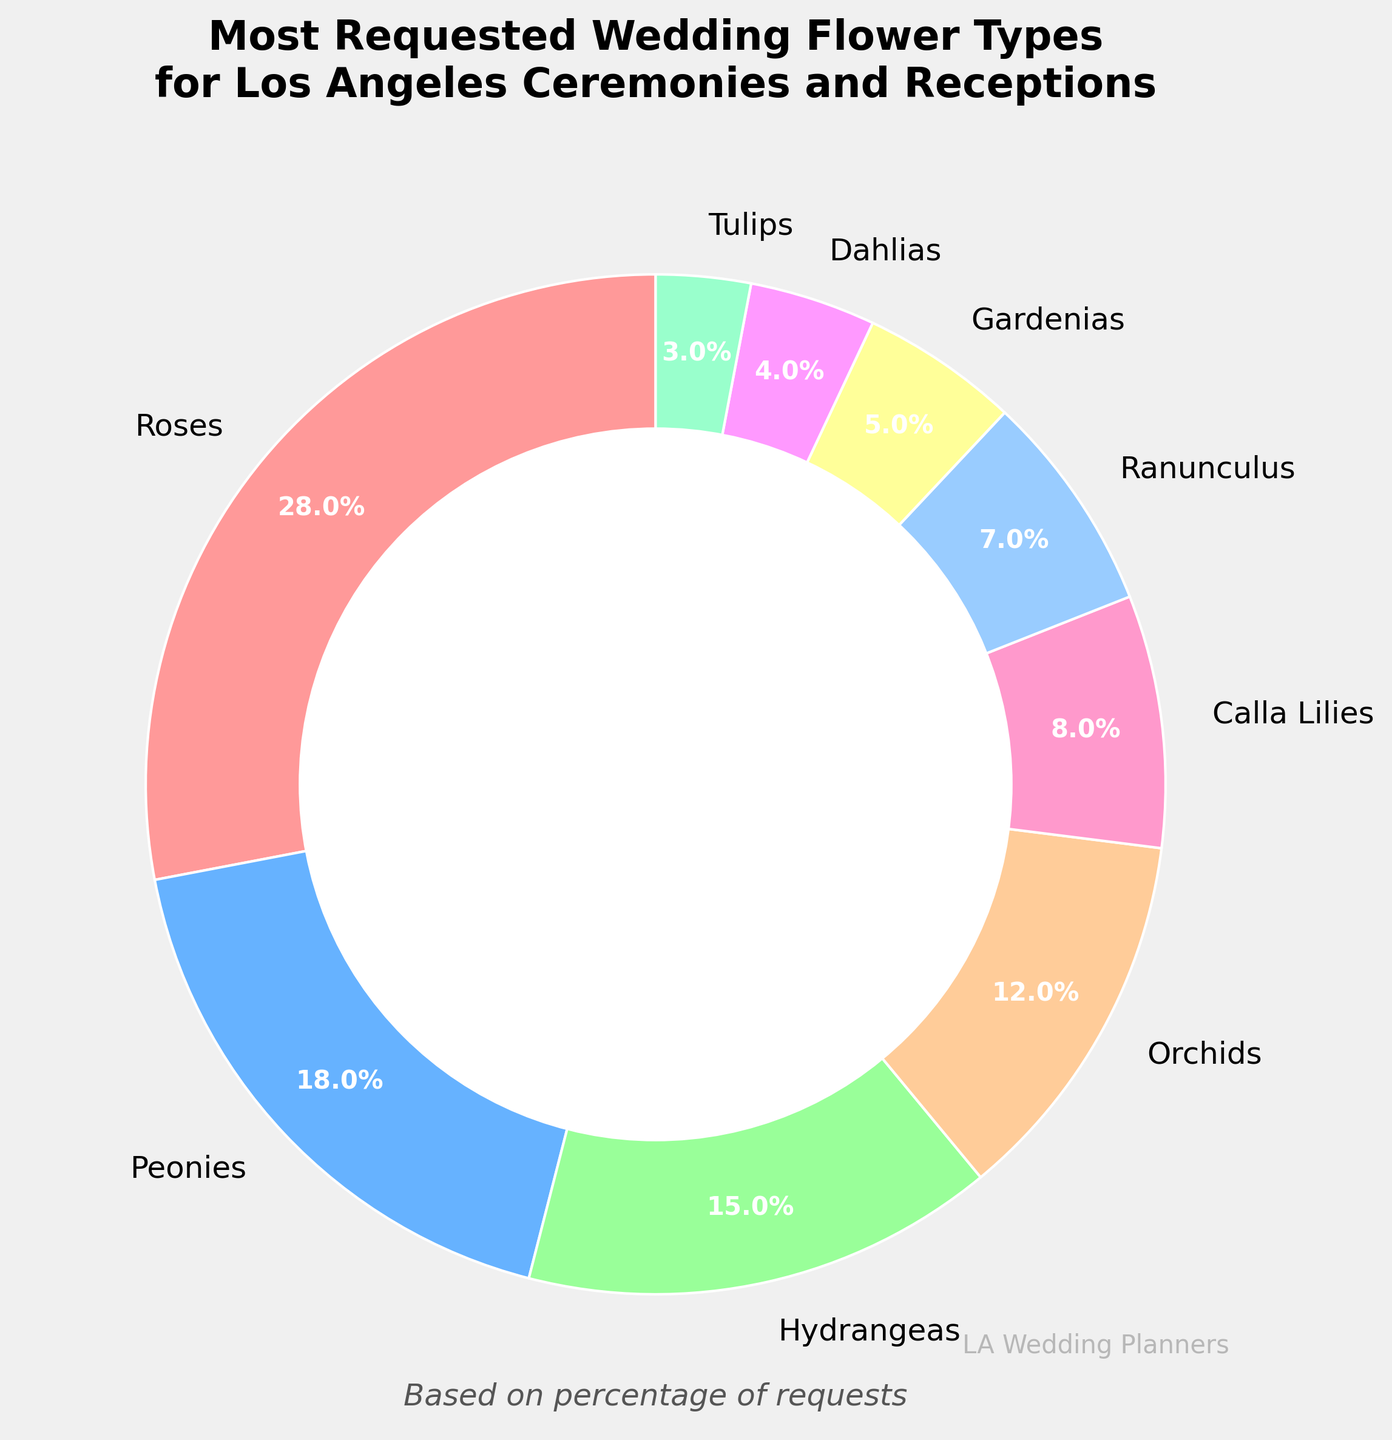How much more requested are Roses compared to Orchids? First, identify the percentages for Roses (28%) and Orchids (12%) from the chart. Then, calculate the difference: 28% - 12% = 16%.
Answer: 16% Which flower type has the second highest request percentage after Roses? From the chart, identify the percentage of each flower type. Roses have the highest percentage at 28%, followed by Peonies with 18%.
Answer: Peonies What is the total percentage of requests for Gardenias, Dahlias, and Tulips combined? Identify the percentages for Gardenias (5%), Dahlias (4%), and Tulips (3%) from the chart. Sum these percentages: 5% + 4% + 3% = 12%.
Answer: 12% Are Calla Lilies requested more or less than Ranunculus? Compare the percentages for Calla Lilies (8%) and Ranunculus (7%). Calla Lilies have a higher percentage than Ranunculus.
Answer: More What fraction of the total requested flowers do Hydrangeas and Orchids together constitute? Identify the percentages for Hydrangeas (15%) and Orchids (12%). Sum these percentages: 15% + 12% = 27%. Then convert this percentage to a fraction: 27/100 = 0.27.
Answer: 27% Which flower types have a request percentage of less than 10%? Identify the flower types with percentages less than 10% from the chart. These are Calla Lilies (8%), Ranunculus (7%), Gardenias (5%), Dahlias (4%), and Tulips (3%).
Answer: Calla Lilies, Ranunculus, Gardenias, Dahlias, Tulips How does the request percentage for Roses compare to the combined percentage for Ranunculus, Gardenias, and Dahlias? Identify the percentages for Roses (28%), Ranunculus (7%), Gardenias (5%), and Dahlias (4%). Sum the percentages for Ranunculus, Gardenias, and Dahlias: 7% + 5% + 4% = 16%. Compare this to Roses' percentage: 28% vs. 16%.
Answer: Roses are more requested What visual feature is used to indicate the difference between the flower types? The pie chart uses different colors to visually distinguish between each flower type.
Answer: Different colors What's the combined percentage of the two least requested flower types? Identify the percentages of the two least requested flower types, Dahlias (4%) and Tulips (3%). Sum these percentages: 4% + 3% = 7%.
Answer: 7% 